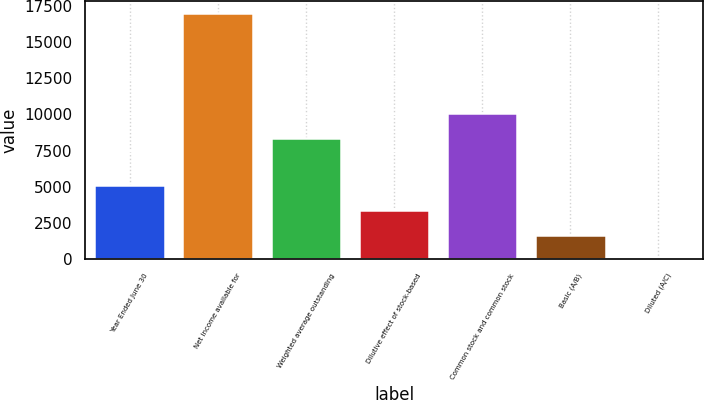Convert chart. <chart><loc_0><loc_0><loc_500><loc_500><bar_chart><fcel>Year Ended June 30<fcel>Net income available for<fcel>Weighted average outstanding<fcel>Dilutive effect of stock-based<fcel>Common stock and common stock<fcel>Basic (A/B)<fcel>Diluted (A/C)<nl><fcel>5094.8<fcel>16978<fcel>8396<fcel>3397.2<fcel>10093.6<fcel>1699.6<fcel>2<nl></chart> 